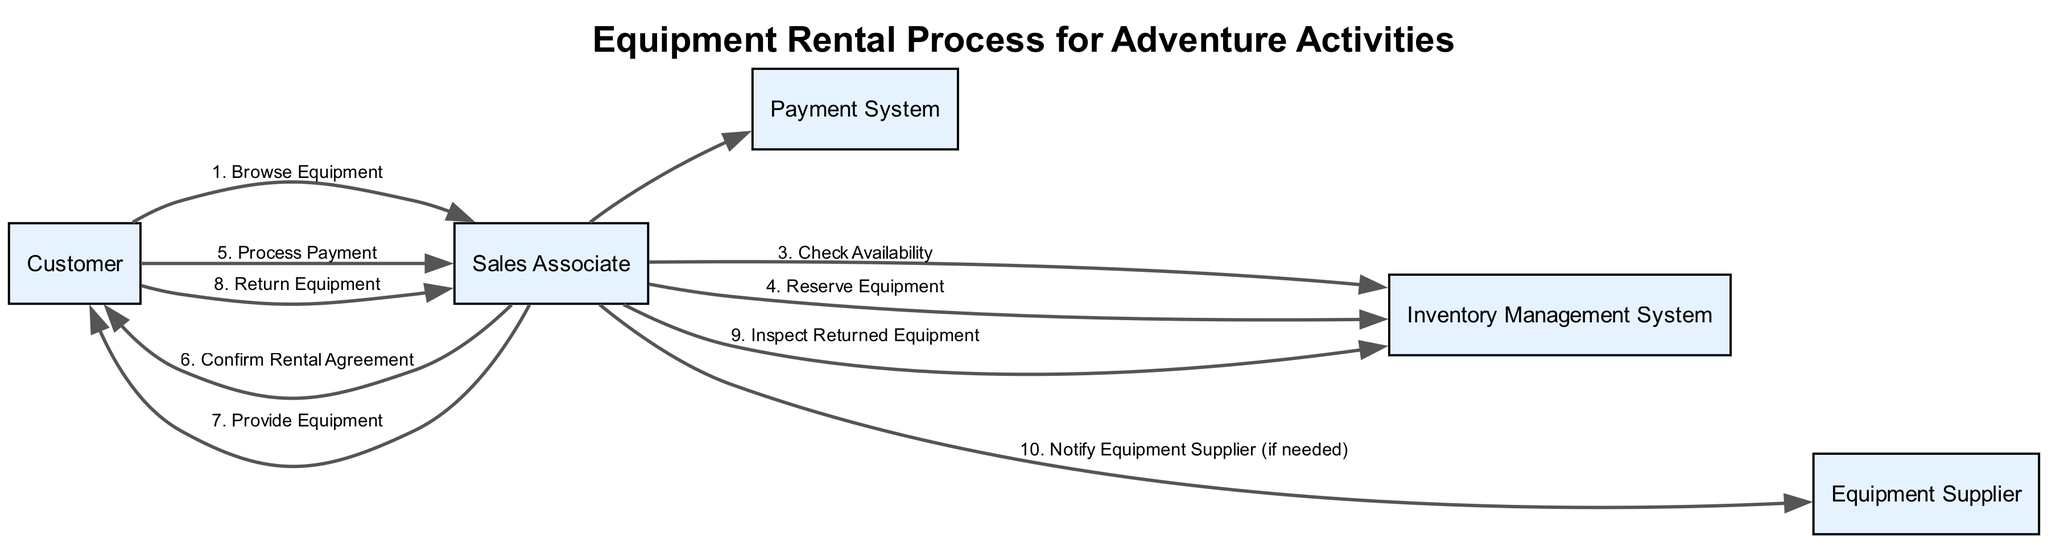What is the first action in the rental process? The first action in the process is listed as step 1, which is "Browse Equipment". This is clearly marked at the beginning of the sequence.
Answer: Browse Equipment How many participants are involved in the process? There are five participants identified in the diagram: Customer, Sales Associate, Payment System, Inventory Management System, and Equipment Supplier. Counting each one gives us a total of five.
Answer: 5 Which participant checks the availability of equipment? The action "Check Availability" is conducted by the Sales Associate as well as the Inventory Management System, as indicated in step 3 of the process.
Answer: Sales Associate What is the step number for "Process Payment"? The action "Process Payment" occurs at step number 5, as can be referenced in the sequential listing of the process actions.
Answer: 5 How many steps involve the Sales Associate? By reviewing the steps outlined, the Sales Associate is involved in steps 1 (with Customer), 3, 4, 5, 6, 7, 9, and 10, resulting in a total of seven steps where this participant has a role.
Answer: 7 Who is responsible for notifying the Equipment Supplier? "Notify Equipment Supplier (if needed)" is the action specified in step 10, and it is carried out by the Sales Associate, as listed in the involved parties for that step.
Answer: Sales Associate What is the last action in the equipment rental process? The last action mentioned in the sequence is step 10, titled "Notify Equipment Supplier (if needed)", which concludes the process.
Answer: Notify Equipment Supplier (if needed) What happens after "Reserve Equipment"? Following step 4 "Reserve Equipment", the next action is step 5, "Process Payment", which indicates a progression in the process toward finalizing the rental.
Answer: Process Payment Which action is performed by both the Customer and Sales Associate together? The actions "Browse Equipment", "Confirm Rental Agreement", and "Provide Equipment" are all carried out with participation from both the Customer and the Sales Associate, illustrating collaborative steps in the process.
Answer: Browse Equipment, Confirm Rental Agreement, Provide Equipment 